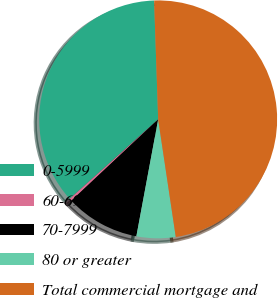<chart> <loc_0><loc_0><loc_500><loc_500><pie_chart><fcel>0-5999<fcel>60-6999<fcel>70-7999<fcel>80 or greater<fcel>Total commercial mortgage and<nl><fcel>36.1%<fcel>0.34%<fcel>10.08%<fcel>5.3%<fcel>48.18%<nl></chart> 